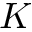<formula> <loc_0><loc_0><loc_500><loc_500>K</formula> 